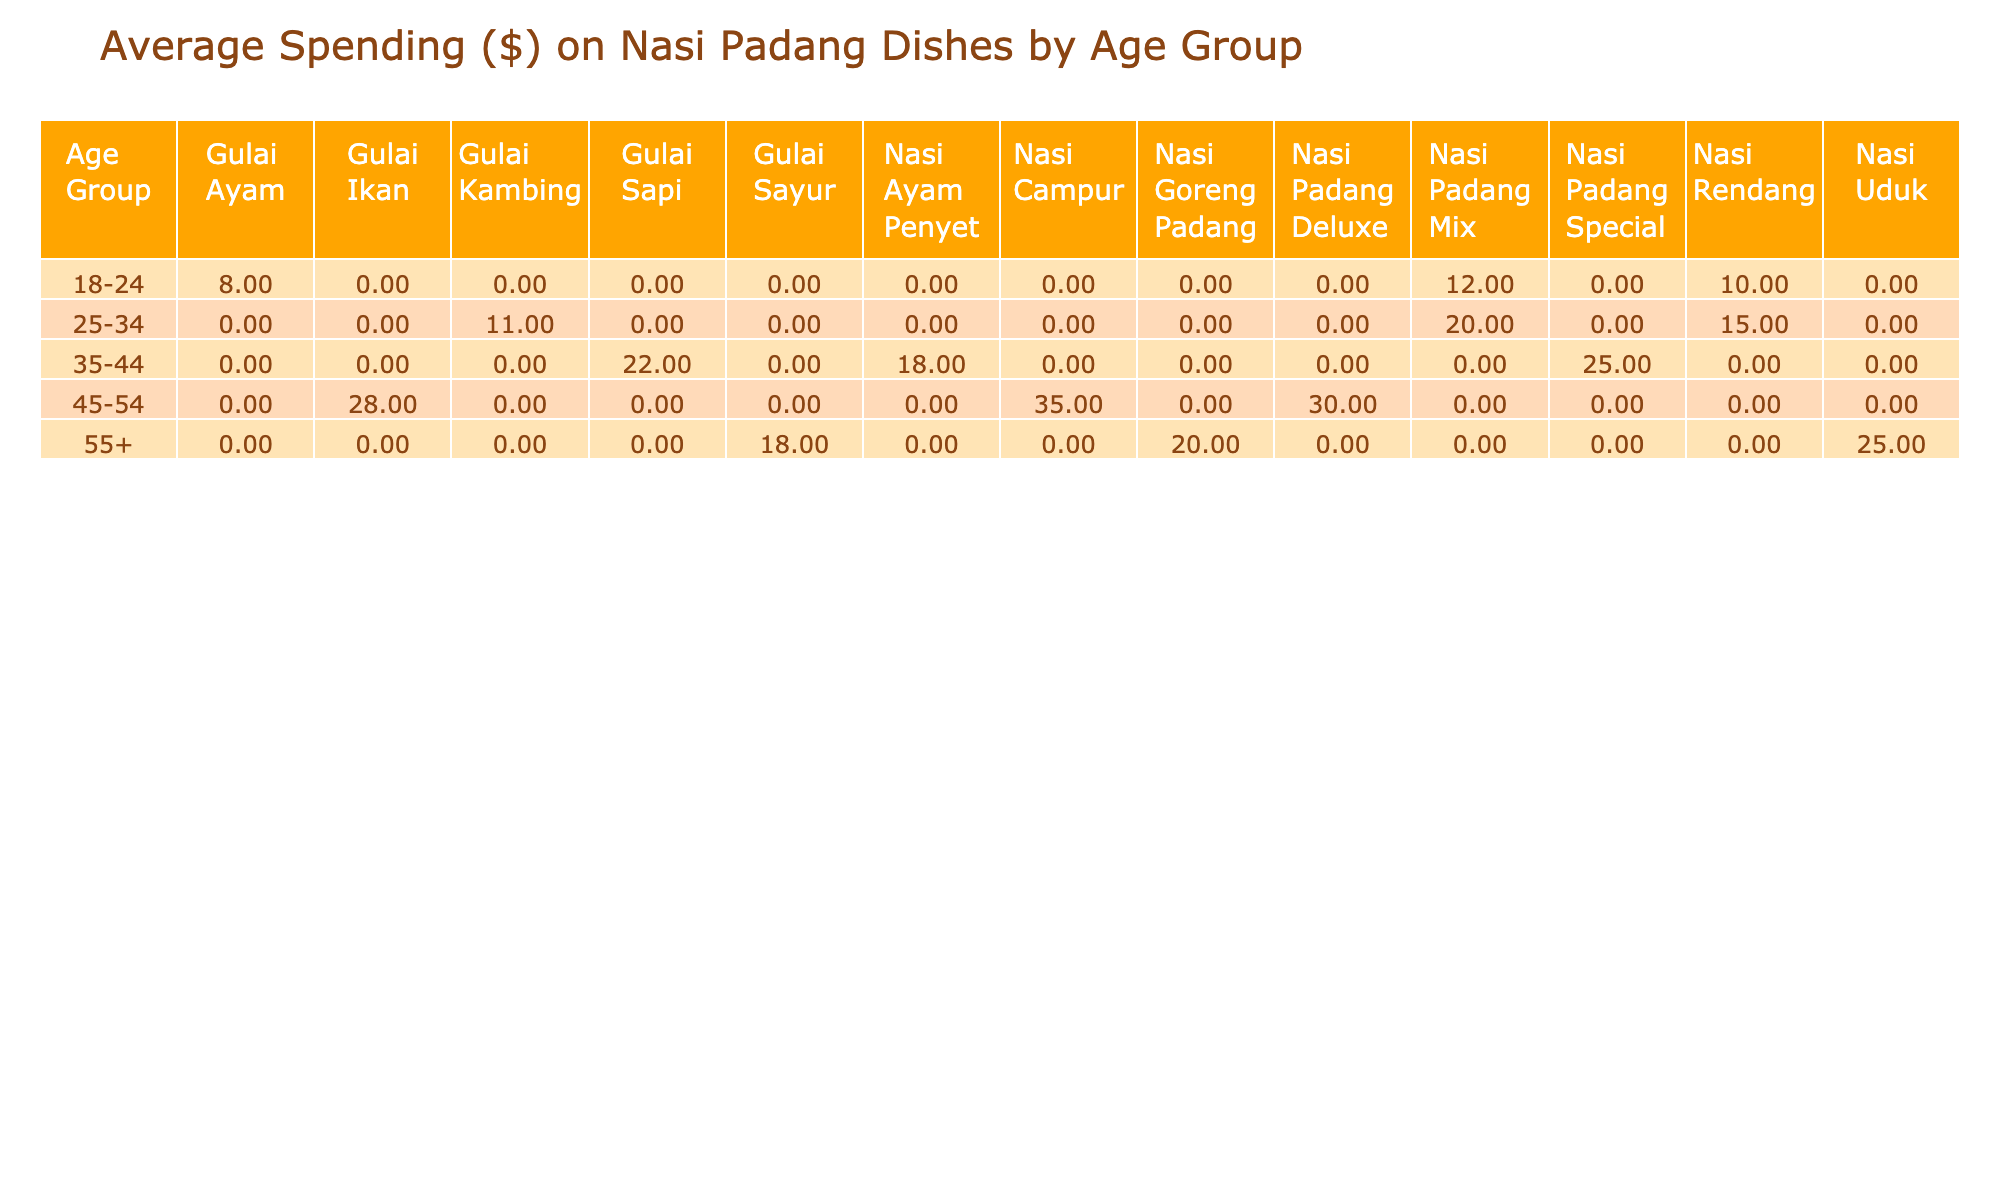What is the average spending on Nasi Padang Mix for the age group 25-34? For the age group 25-34, the average spending on Nasi Padang Mix is calculated from one entry which is 20. Since there's only one value, the average is also 20.
Answer: 20 Which age group spends the most on Nasi Padang Deluxe? The age group 45-54 has one entry for Nasi Padang Deluxe with a spending of 30. No other age group spends on this dish, so 45-54 is the only group.
Answer: 45-54 Is the average spending on Gulai Kambing for the age group 25-34 higher than for Gulai Sayur in the age group 55+? The average spending on Gulai Kambing for the age group 25-34 is 11, while for Gulai Sayur in age group 55+, it is 18. Since 11 is less than 18, the answer is no.
Answer: No What is the total average spending for all dishes liked by the 35-44 age group? The spending for the 35-44 age group includes Nasi Ayam Penyet (18), Nasi Padang Special (25), and Gulai Sapi (22). The total spending is 18 + 25 + 22 = 65, and there are 3 entries, so the average is 65/3 = approximately 21.67.
Answer: 21.67 Which dish is the most preferred among the 45-54 age group based on average spending? The dishes preferred by the 45-54 age group are Nasi Padang Deluxe (30), Gulai Ikan (28), and Nasi Campur (35). The one with the highest spending is Nasi Campur with 35.
Answer: Nasi Campur How many age groups show a preference for Nasi Rendang, and what is their average spending? Nasi Rendang is preferred by two age groups: 18-24 (spending 10) and 25-34 (spending 15). The average spending is (10 + 15) / 2 = 12.5. Thus, there are 2 age groups with an average spending of 12.5.
Answer: 2 age groups, 12.5 Does any age group exhibit a spending that exceeds 30 dollars on dishes? Yes, the 45-54 age group has a spending of 35 on Nasi Campur, which exceeds 30.
Answer: Yes What is the combined spending of all dishes for the age group 55+? The age group 55+ has three dishes: Nasi Goreng Padang (20), Gulai Sayur (18), and Nasi Uduk (25). Adding those gives 20 + 18 + 25 = 63.
Answer: 63 